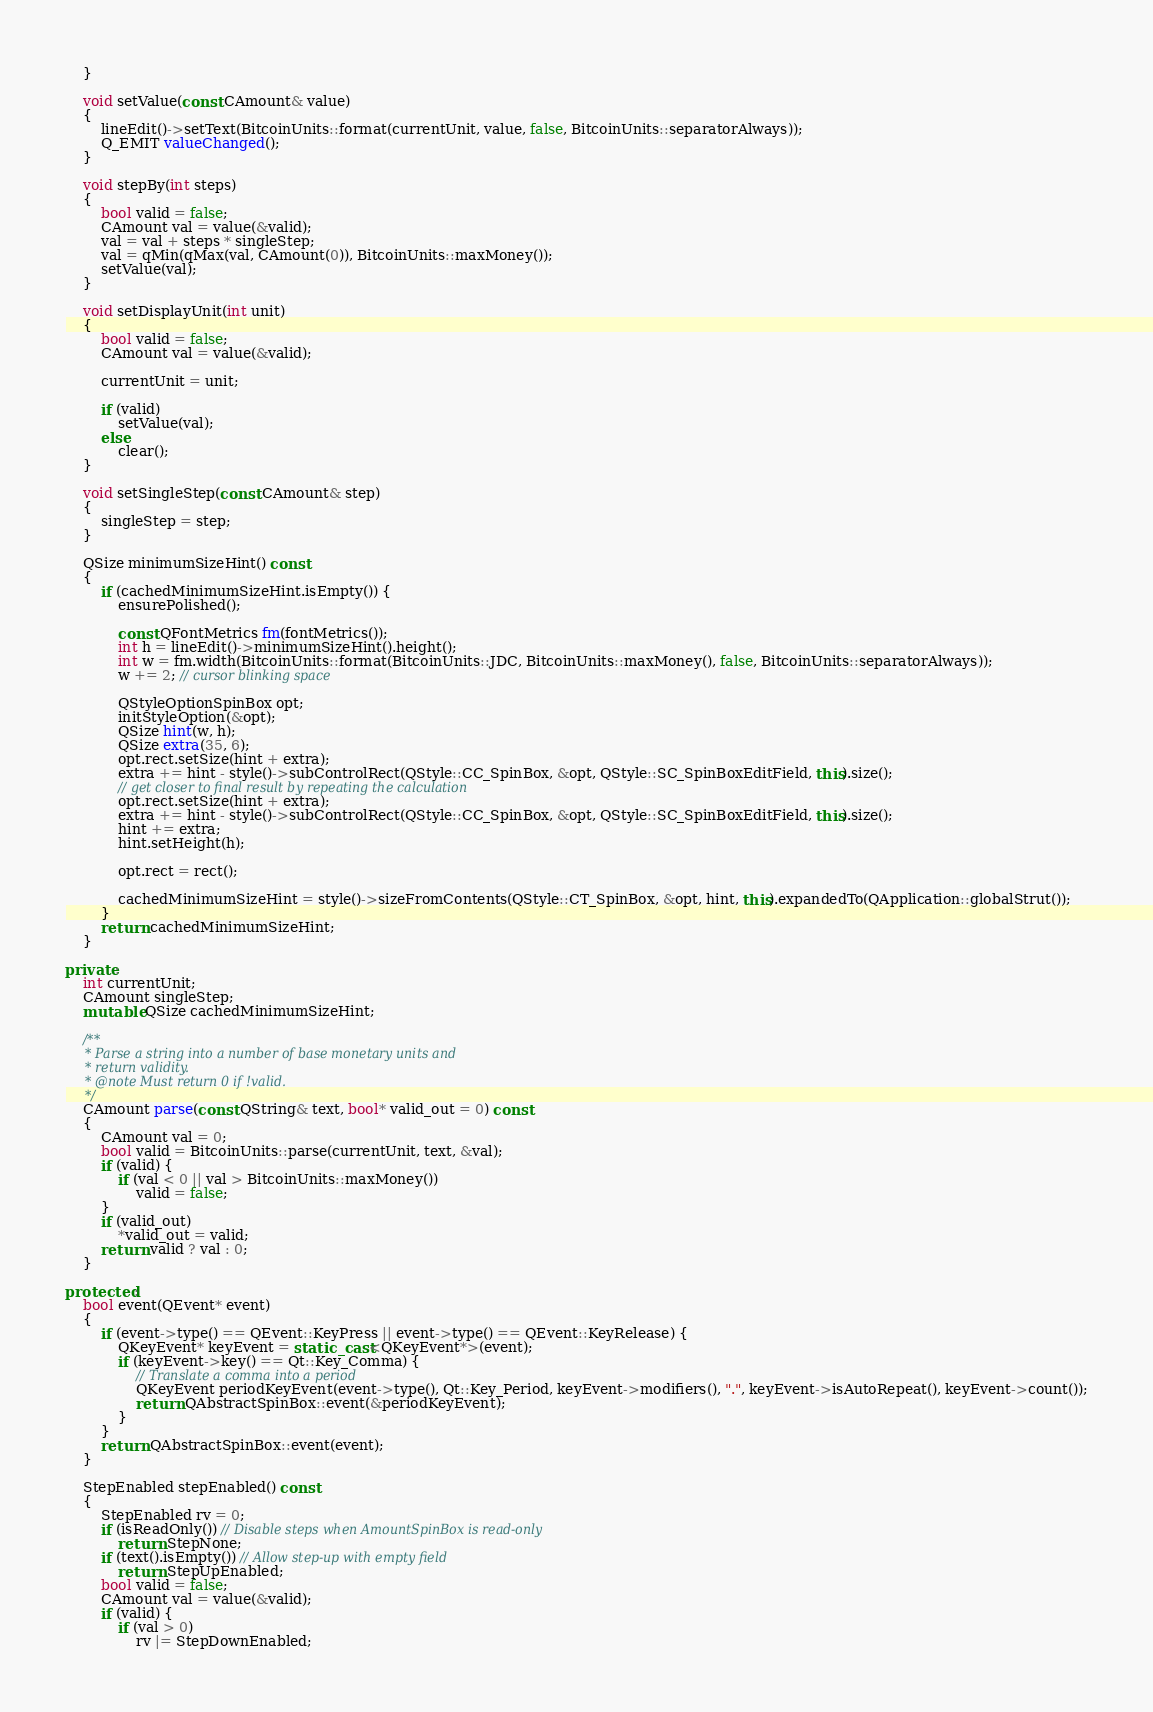<code> <loc_0><loc_0><loc_500><loc_500><_C++_>    }

    void setValue(const CAmount& value)
    {
        lineEdit()->setText(BitcoinUnits::format(currentUnit, value, false, BitcoinUnits::separatorAlways));
        Q_EMIT valueChanged();
    }

    void stepBy(int steps)
    {
        bool valid = false;
        CAmount val = value(&valid);
        val = val + steps * singleStep;
        val = qMin(qMax(val, CAmount(0)), BitcoinUnits::maxMoney());
        setValue(val);
    }

    void setDisplayUnit(int unit)
    {
        bool valid = false;
        CAmount val = value(&valid);

        currentUnit = unit;

        if (valid)
            setValue(val);
        else
            clear();
    }

    void setSingleStep(const CAmount& step)
    {
        singleStep = step;
    }

    QSize minimumSizeHint() const
    {
        if (cachedMinimumSizeHint.isEmpty()) {
            ensurePolished();

            const QFontMetrics fm(fontMetrics());
            int h = lineEdit()->minimumSizeHint().height();
            int w = fm.width(BitcoinUnits::format(BitcoinUnits::JDC, BitcoinUnits::maxMoney(), false, BitcoinUnits::separatorAlways));
            w += 2; // cursor blinking space

            QStyleOptionSpinBox opt;
            initStyleOption(&opt);
            QSize hint(w, h);
            QSize extra(35, 6);
            opt.rect.setSize(hint + extra);
            extra += hint - style()->subControlRect(QStyle::CC_SpinBox, &opt, QStyle::SC_SpinBoxEditField, this).size();
            // get closer to final result by repeating the calculation
            opt.rect.setSize(hint + extra);
            extra += hint - style()->subControlRect(QStyle::CC_SpinBox, &opt, QStyle::SC_SpinBoxEditField, this).size();
            hint += extra;
            hint.setHeight(h);

            opt.rect = rect();

            cachedMinimumSizeHint = style()->sizeFromContents(QStyle::CT_SpinBox, &opt, hint, this).expandedTo(QApplication::globalStrut());
        }
        return cachedMinimumSizeHint;
    }

private:
    int currentUnit;
    CAmount singleStep;
    mutable QSize cachedMinimumSizeHint;

    /**
     * Parse a string into a number of base monetary units and
     * return validity.
     * @note Must return 0 if !valid.
     */
    CAmount parse(const QString& text, bool* valid_out = 0) const
    {
        CAmount val = 0;
        bool valid = BitcoinUnits::parse(currentUnit, text, &val);
        if (valid) {
            if (val < 0 || val > BitcoinUnits::maxMoney())
                valid = false;
        }
        if (valid_out)
            *valid_out = valid;
        return valid ? val : 0;
    }

protected:
    bool event(QEvent* event)
    {
        if (event->type() == QEvent::KeyPress || event->type() == QEvent::KeyRelease) {
            QKeyEvent* keyEvent = static_cast<QKeyEvent*>(event);
            if (keyEvent->key() == Qt::Key_Comma) {
                // Translate a comma into a period
                QKeyEvent periodKeyEvent(event->type(), Qt::Key_Period, keyEvent->modifiers(), ".", keyEvent->isAutoRepeat(), keyEvent->count());
                return QAbstractSpinBox::event(&periodKeyEvent);
            }
        }
        return QAbstractSpinBox::event(event);
    }

    StepEnabled stepEnabled() const
    {
        StepEnabled rv = 0;
        if (isReadOnly()) // Disable steps when AmountSpinBox is read-only
            return StepNone;
        if (text().isEmpty()) // Allow step-up with empty field
            return StepUpEnabled;
        bool valid = false;
        CAmount val = value(&valid);
        if (valid) {
            if (val > 0)
                rv |= StepDownEnabled;</code> 